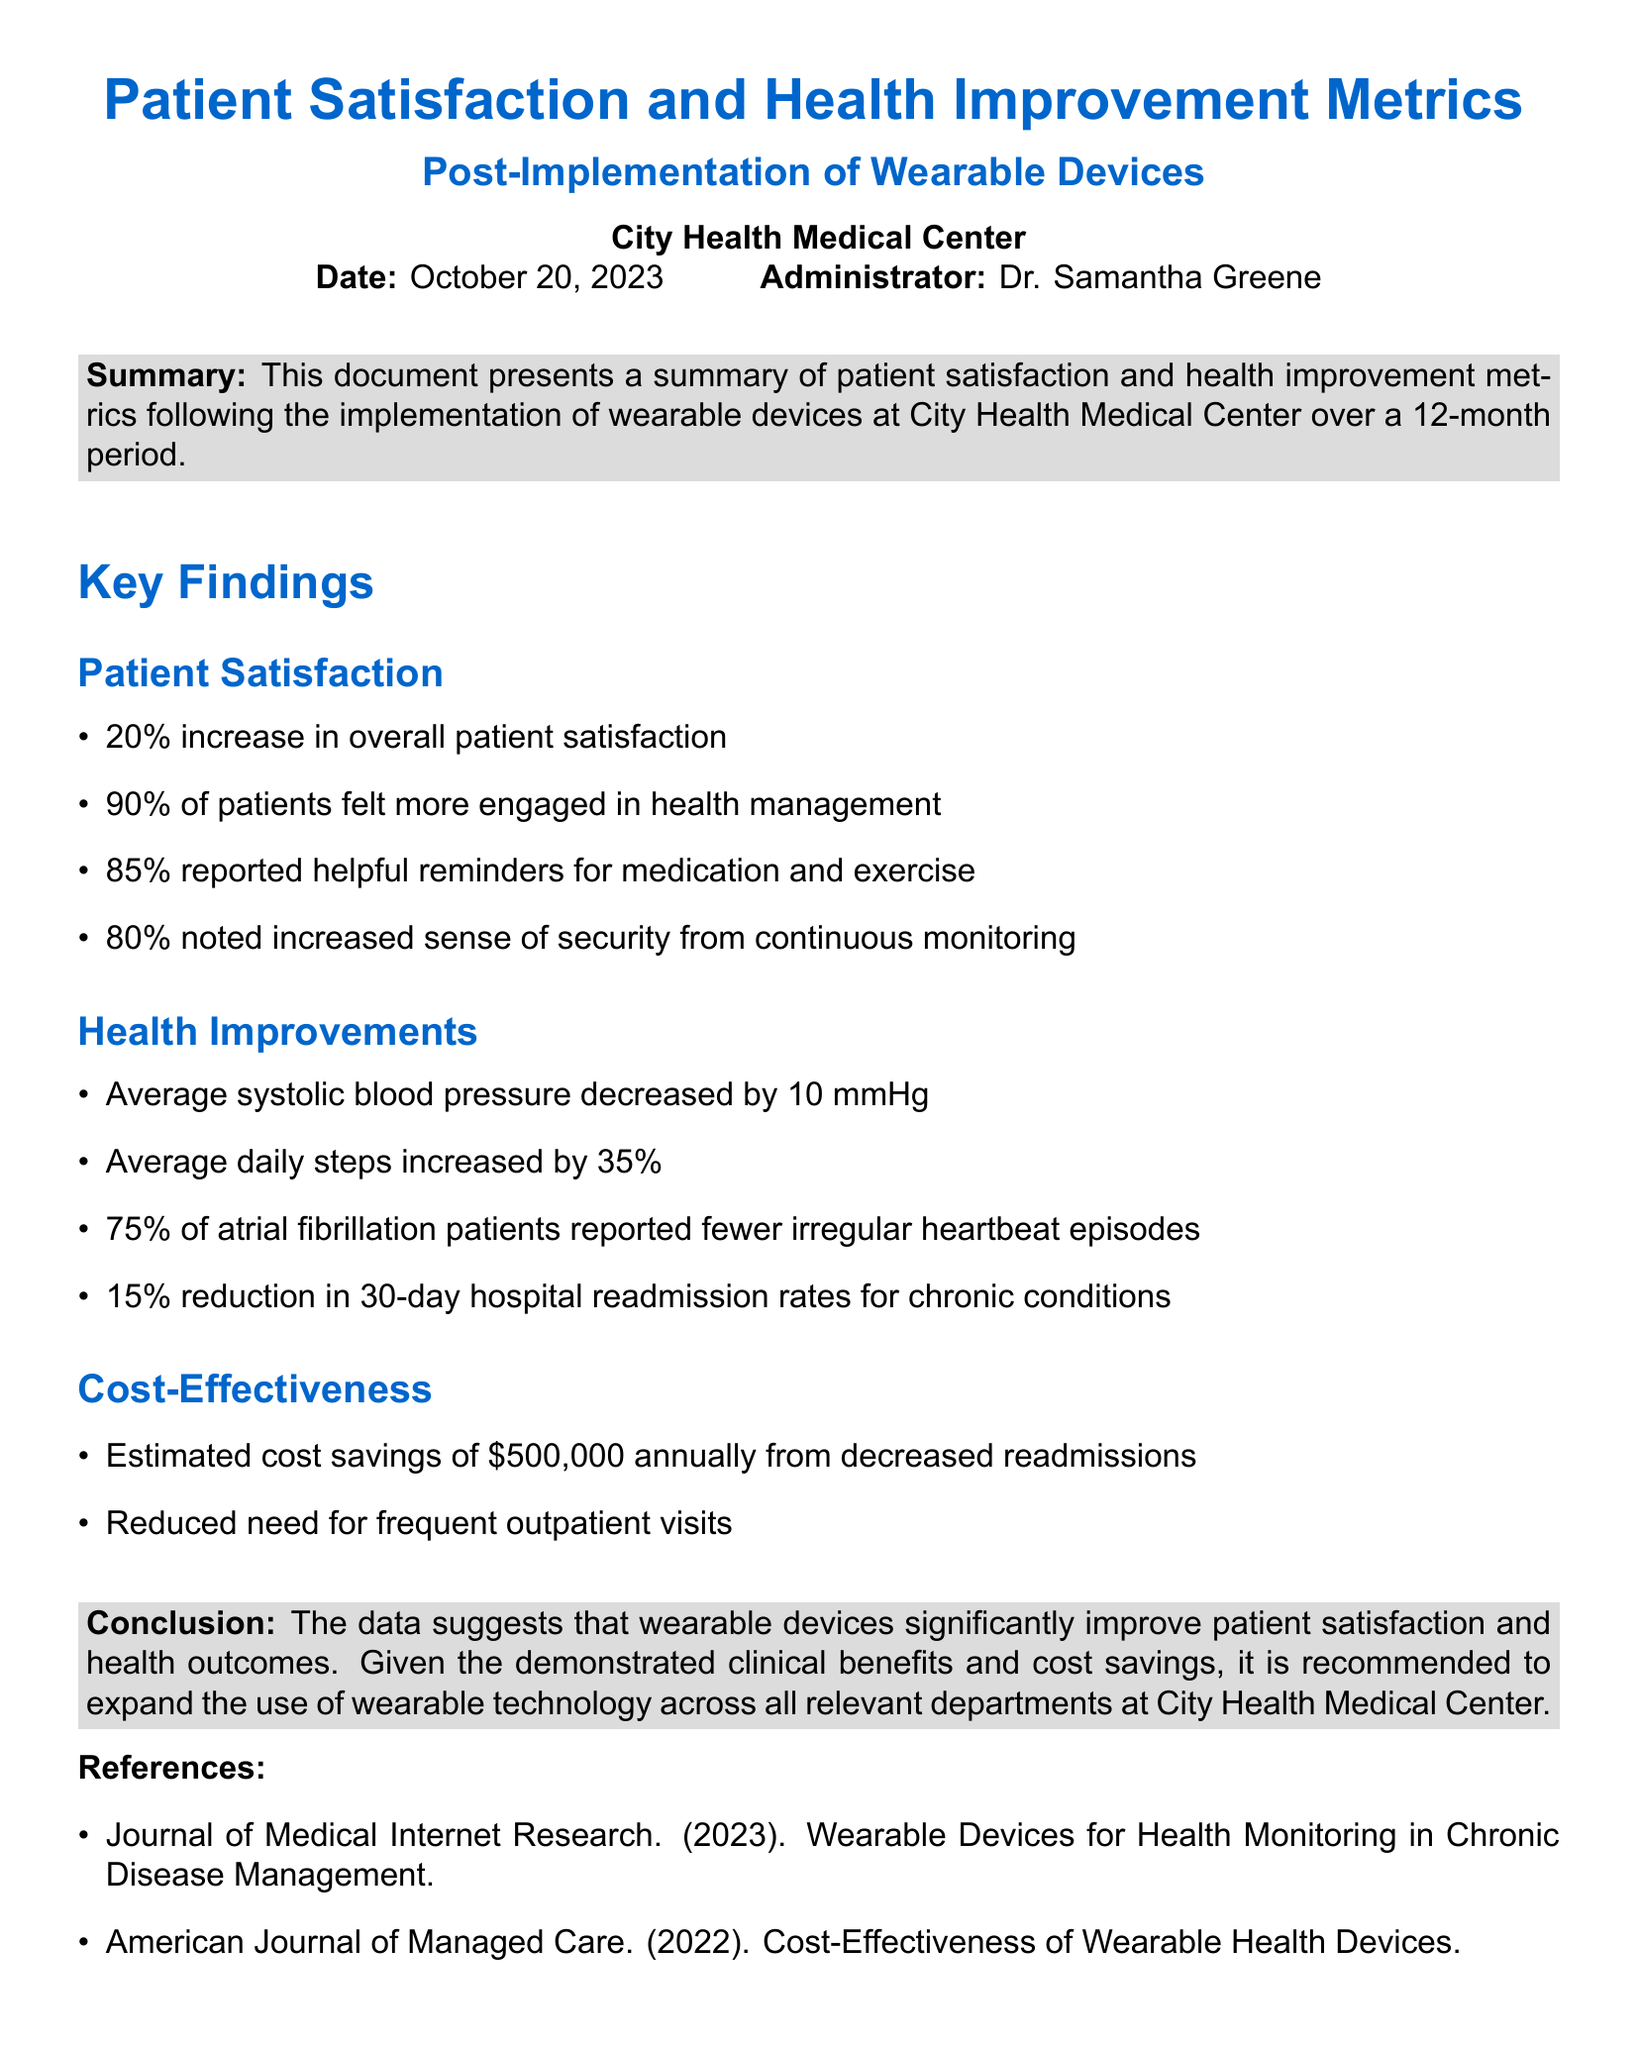what percentage increase was observed in overall patient satisfaction? The document states there was a 20% increase in overall patient satisfaction.
Answer: 20% how many patients felt more engaged in health management? The document mentions that 90% of patients felt more engaged in health management.
Answer: 90% what was the average reduction in systolic blood pressure? The document reports an average decrease in systolic blood pressure of 10 mmHg.
Answer: 10 mmHg what percentage of atrial fibrillation patients reported fewer irregular heartbeat episodes? According to the document, 75% of atrial fibrillation patients reported fewer irregular heartbeat episodes.
Answer: 75% what is the estimated annual cost savings from decreased readmissions? The document estimates annual cost savings of $500,000 from decreased readmissions.
Answer: $500,000 which metric had a 15% reduction and is related to chronic conditions? The document indicates a 15% reduction in 30-day hospital readmission rates for chronic conditions.
Answer: 30-day hospital readmission rates what key emergency service was notably impacted by the use of wearable devices? The document highlights a reduced need for frequent outpatient visits as an impact of wearable devices.
Answer: Reduced need for frequent outpatient visits what conclusion is drawn regarding the use of wearable devices in the document? The document concludes that wearable devices significantly improve patient satisfaction and health outcomes.
Answer: Significant improvement in patient satisfaction and health outcomes who authored the report dated October 20, 2023? The document states that the report was authored by Dr. Samantha Greene on October 20, 2023.
Answer: Dr. Samantha Greene 